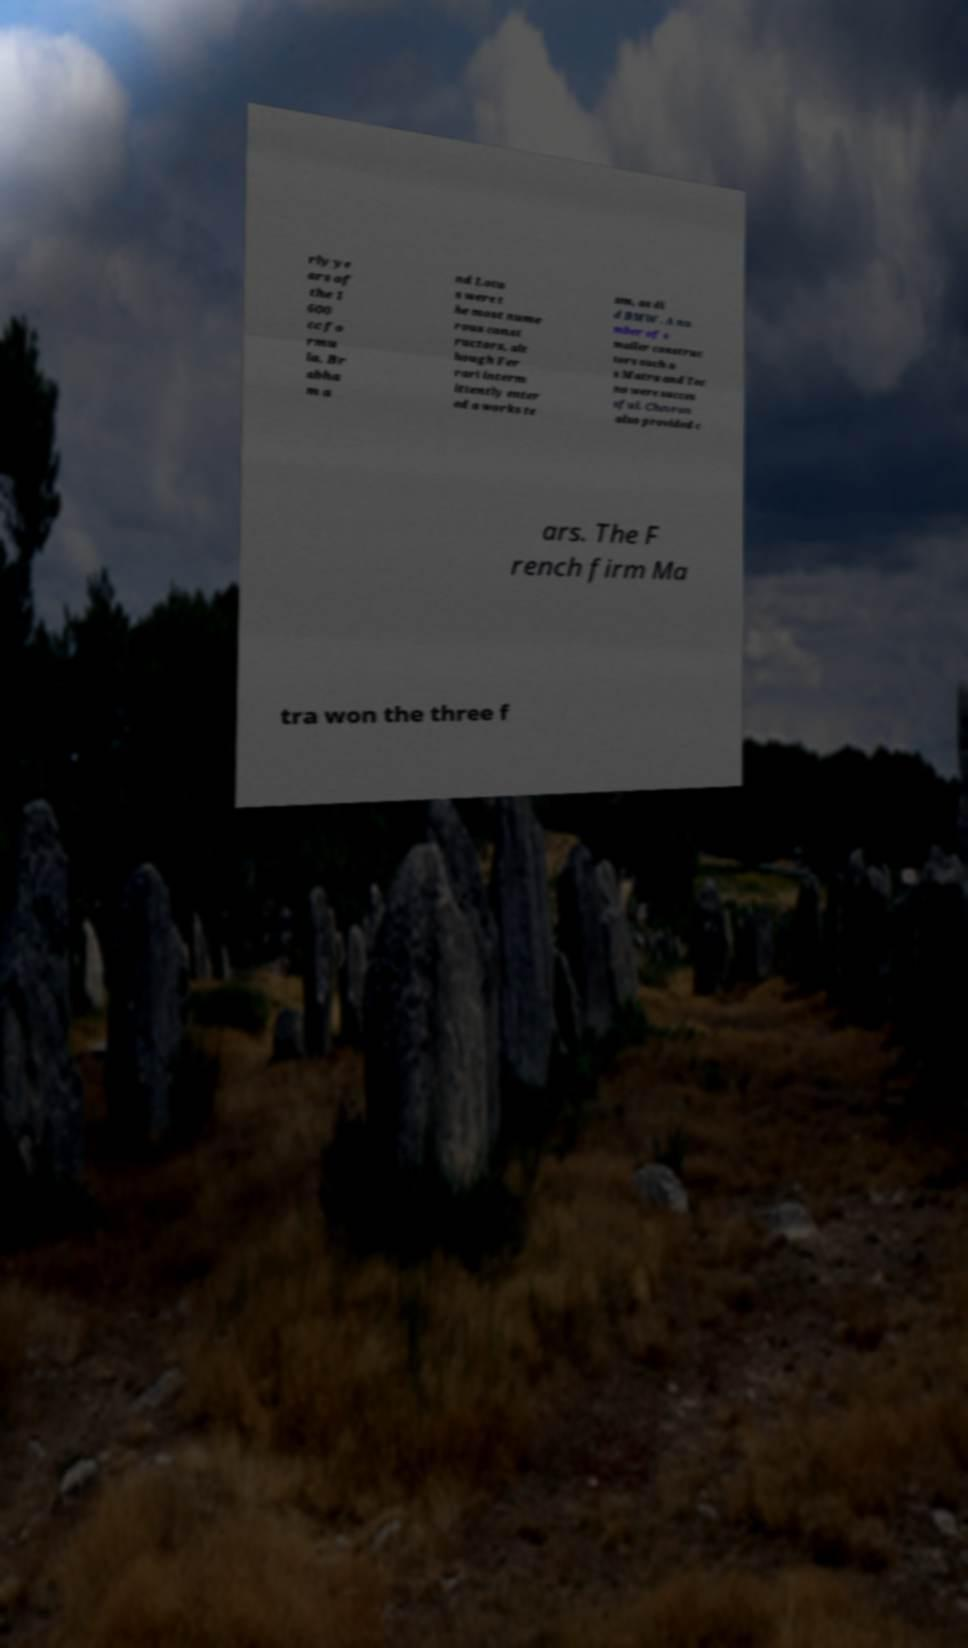Please read and relay the text visible in this image. What does it say? rly ye ars of the 1 600 cc fo rmu la, Br abha m a nd Lotu s were t he most nume rous const ructors, alt hough Fer rari interm ittently enter ed a works te am, as di d BMW . A nu mber of s maller construc tors such a s Matra and Tec no were succes sful. Chevron also provided c ars. The F rench firm Ma tra won the three f 